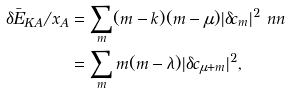Convert formula to latex. <formula><loc_0><loc_0><loc_500><loc_500>\delta \bar { E } _ { K A } / x _ { A } & = \sum _ { m } ( m - k ) ( m - \mu ) | \delta c _ { m } | ^ { 2 } \ n n \\ & = \sum _ { m } m ( m - \lambda ) | \delta c _ { \mu + m } | ^ { 2 } ,</formula> 